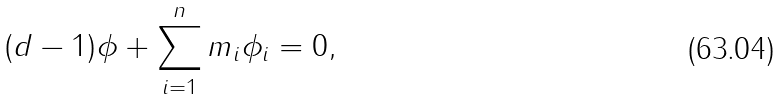<formula> <loc_0><loc_0><loc_500><loc_500>( d - 1 ) \phi + \sum _ { i = 1 } ^ { n } m _ { i } \phi _ { i } = 0 ,</formula> 